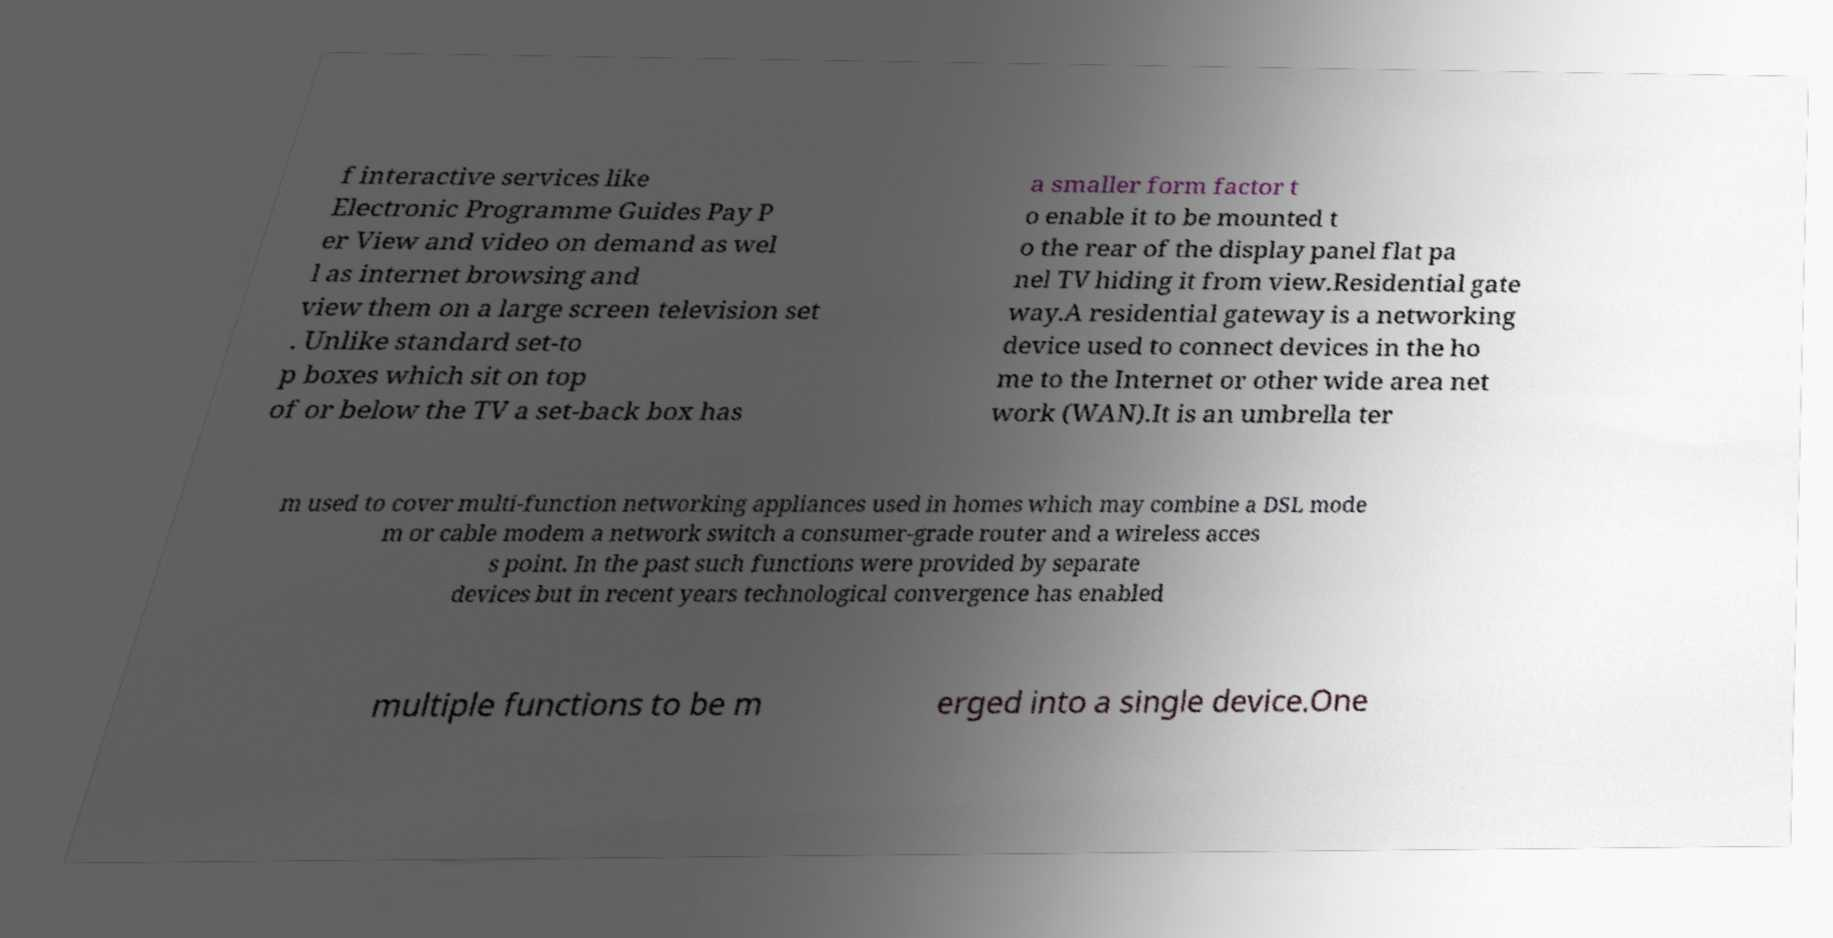Can you accurately transcribe the text from the provided image for me? f interactive services like Electronic Programme Guides Pay P er View and video on demand as wel l as internet browsing and view them on a large screen television set . Unlike standard set-to p boxes which sit on top of or below the TV a set-back box has a smaller form factor t o enable it to be mounted t o the rear of the display panel flat pa nel TV hiding it from view.Residential gate way.A residential gateway is a networking device used to connect devices in the ho me to the Internet or other wide area net work (WAN).It is an umbrella ter m used to cover multi-function networking appliances used in homes which may combine a DSL mode m or cable modem a network switch a consumer-grade router and a wireless acces s point. In the past such functions were provided by separate devices but in recent years technological convergence has enabled multiple functions to be m erged into a single device.One 